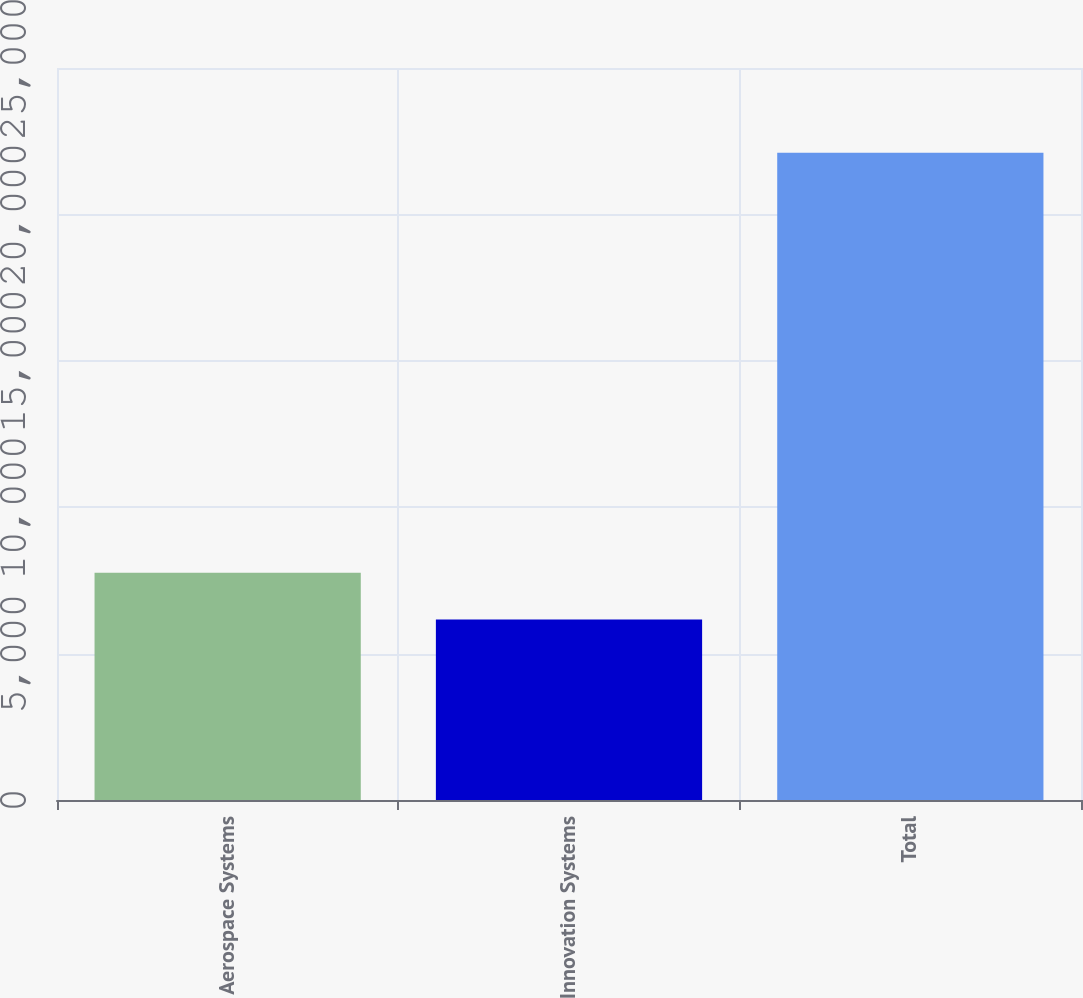Convert chart. <chart><loc_0><loc_0><loc_500><loc_500><bar_chart><fcel>Aerospace Systems<fcel>Innovation Systems<fcel>Total<nl><fcel>7759.2<fcel>6165<fcel>22107<nl></chart> 